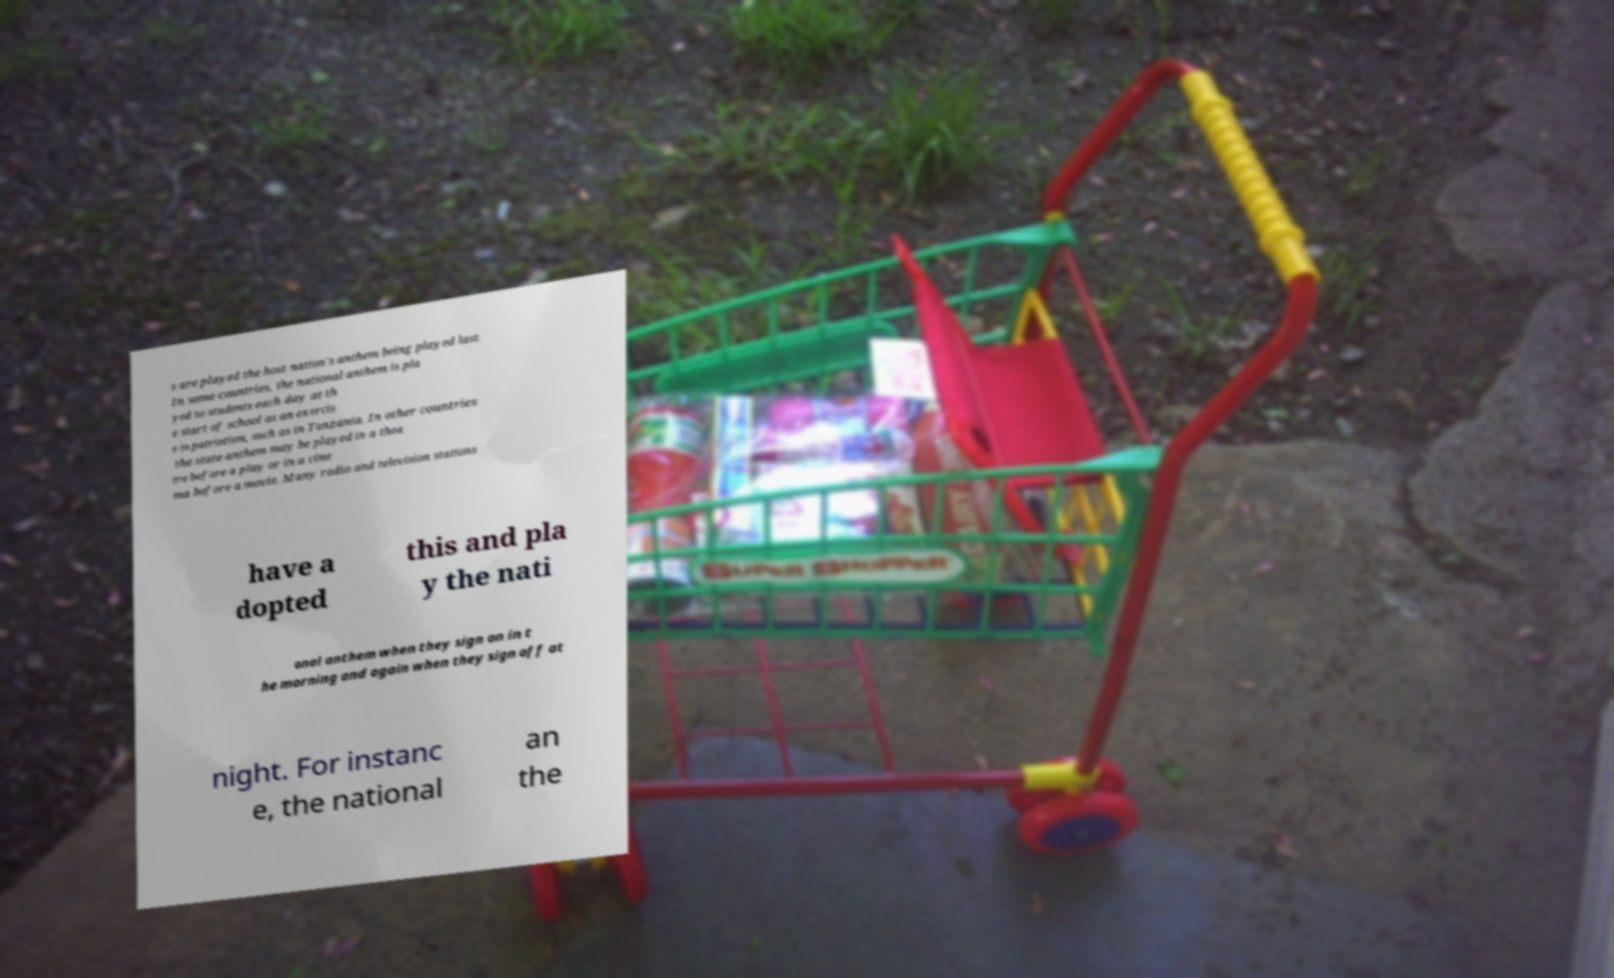Please identify and transcribe the text found in this image. s are played the host nation's anthem being played last. In some countries, the national anthem is pla yed to students each day at th e start of school as an exercis e in patriotism, such as in Tanzania. In other countries the state anthem may be played in a thea tre before a play or in a cine ma before a movie. Many radio and television stations have a dopted this and pla y the nati onal anthem when they sign on in t he morning and again when they sign off at night. For instanc e, the national an the 